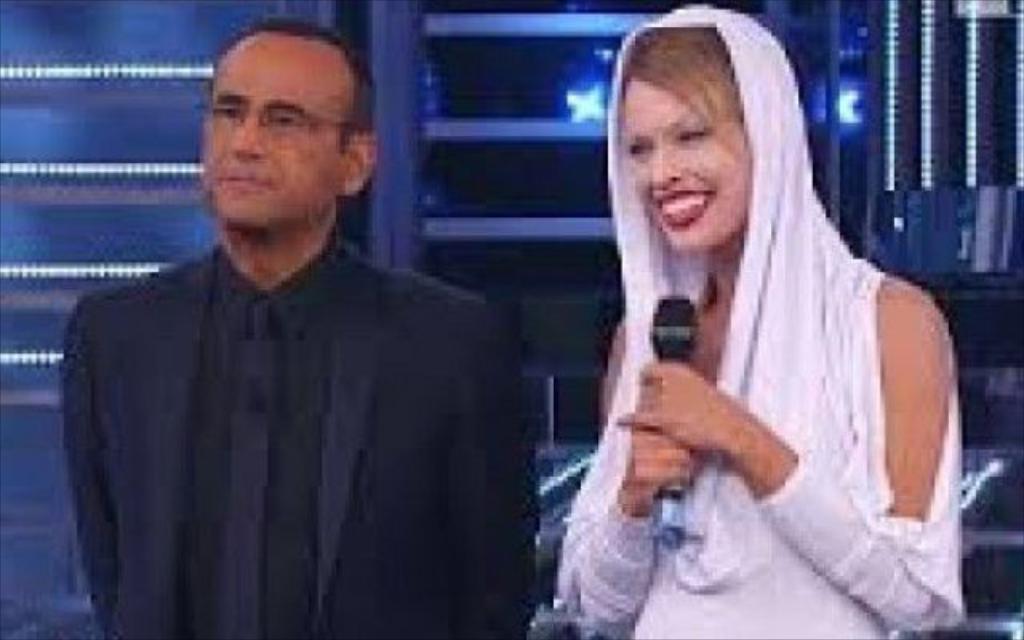How would you summarize this image in a sentence or two? This is the man and woman standing. This woman is holding a mike in her hands. In the background, I can see the lights. 